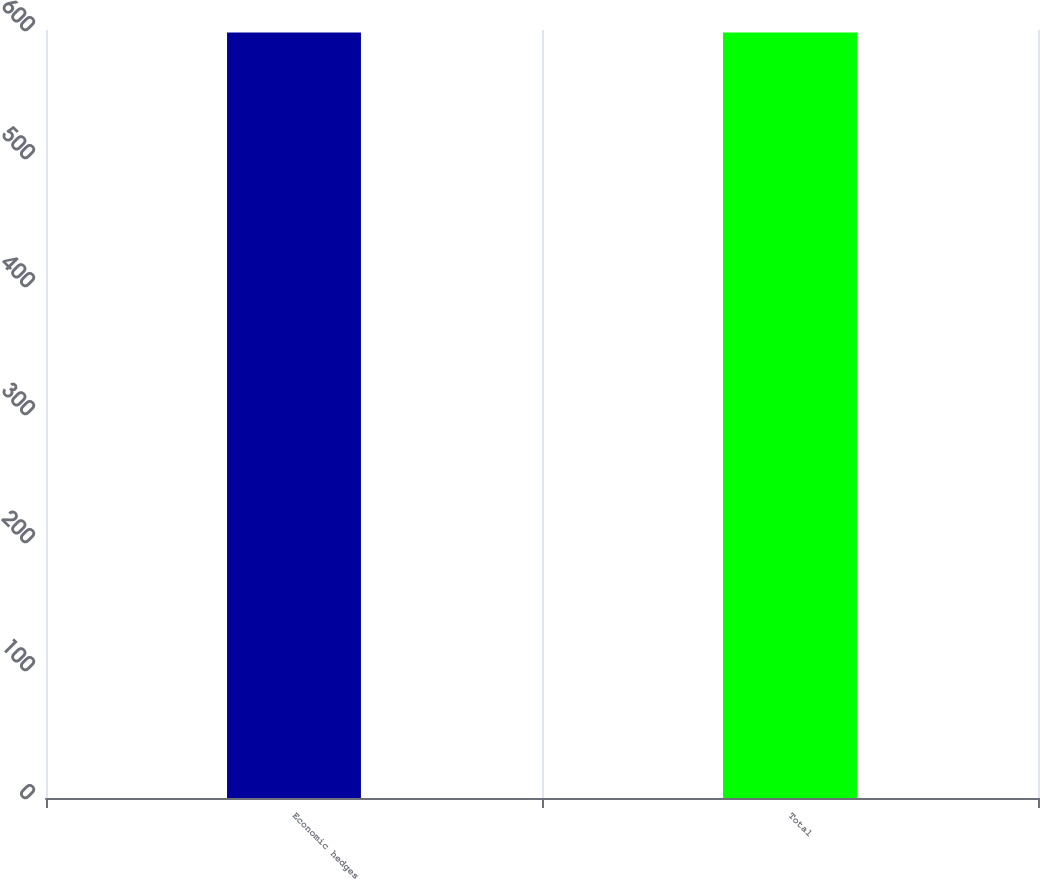<chart> <loc_0><loc_0><loc_500><loc_500><bar_chart><fcel>Economic hedges<fcel>Total<nl><fcel>598<fcel>598.1<nl></chart> 